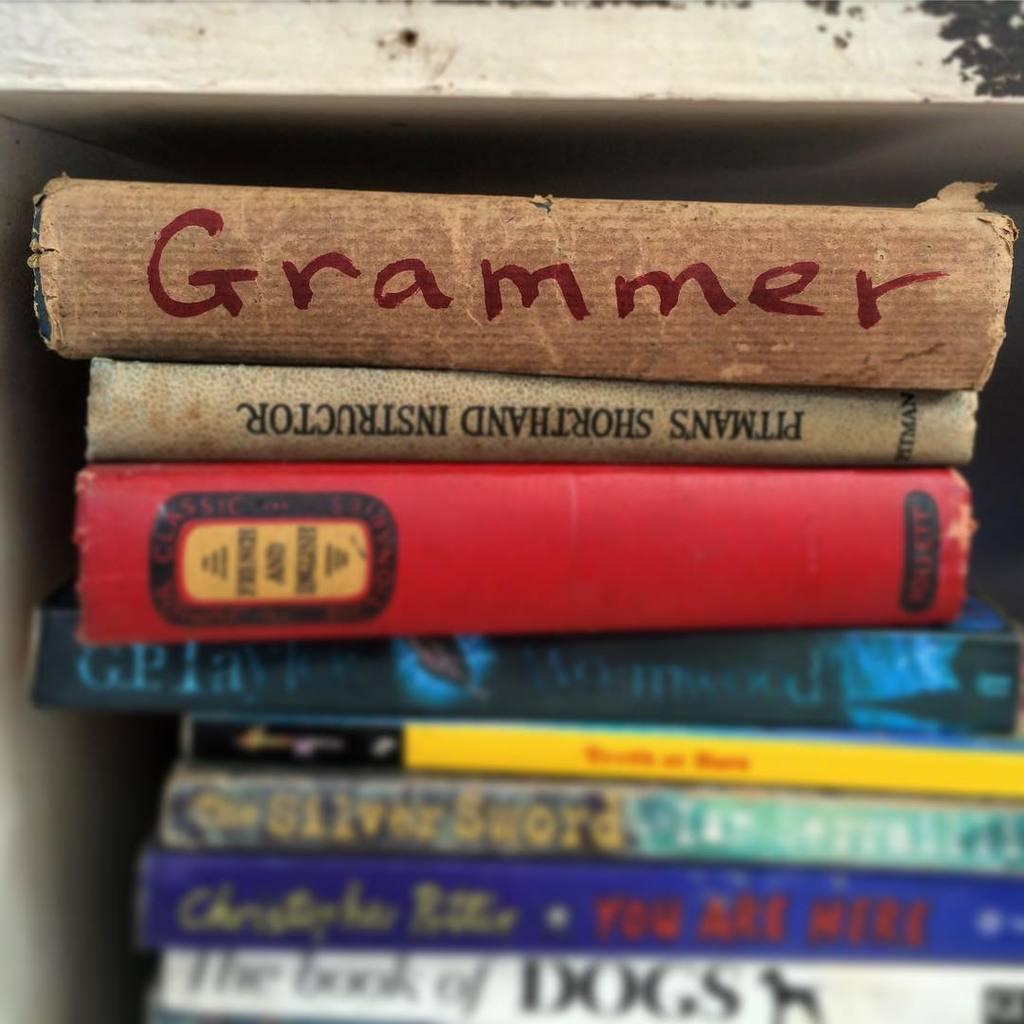<image>
Describe the image concisely. A large stack of different books with one being grammer on top of the stack. 